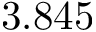Convert formula to latex. <formula><loc_0><loc_0><loc_500><loc_500>3 . 8 4 5</formula> 